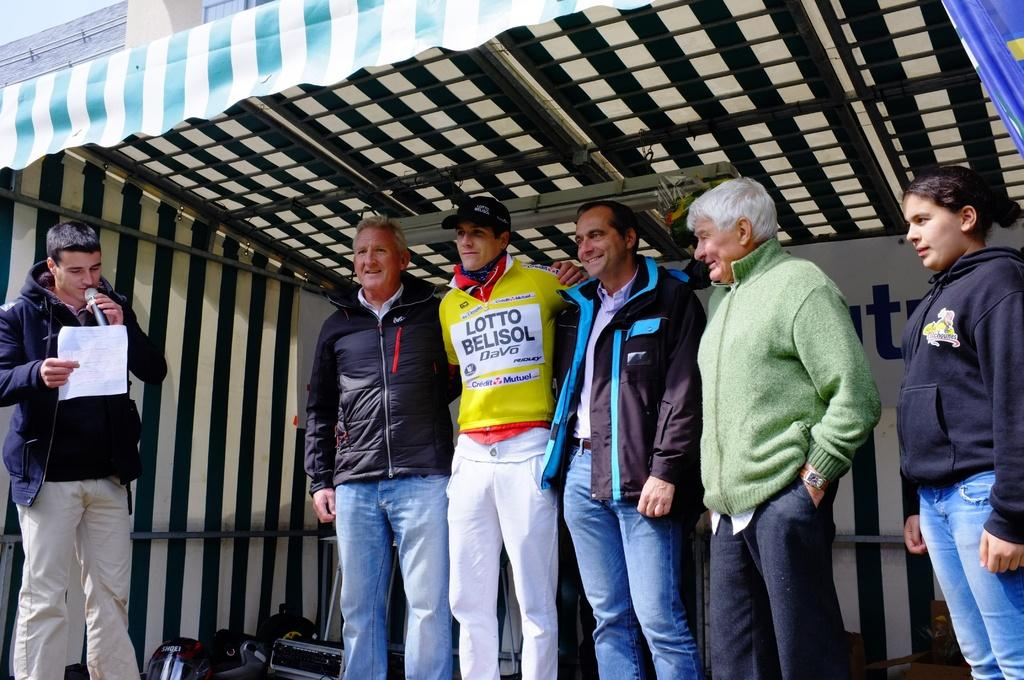Provide a one-sentence caption for the provided image. On a stage, people flank a young man in a LOTTO BELISOL uniform. 